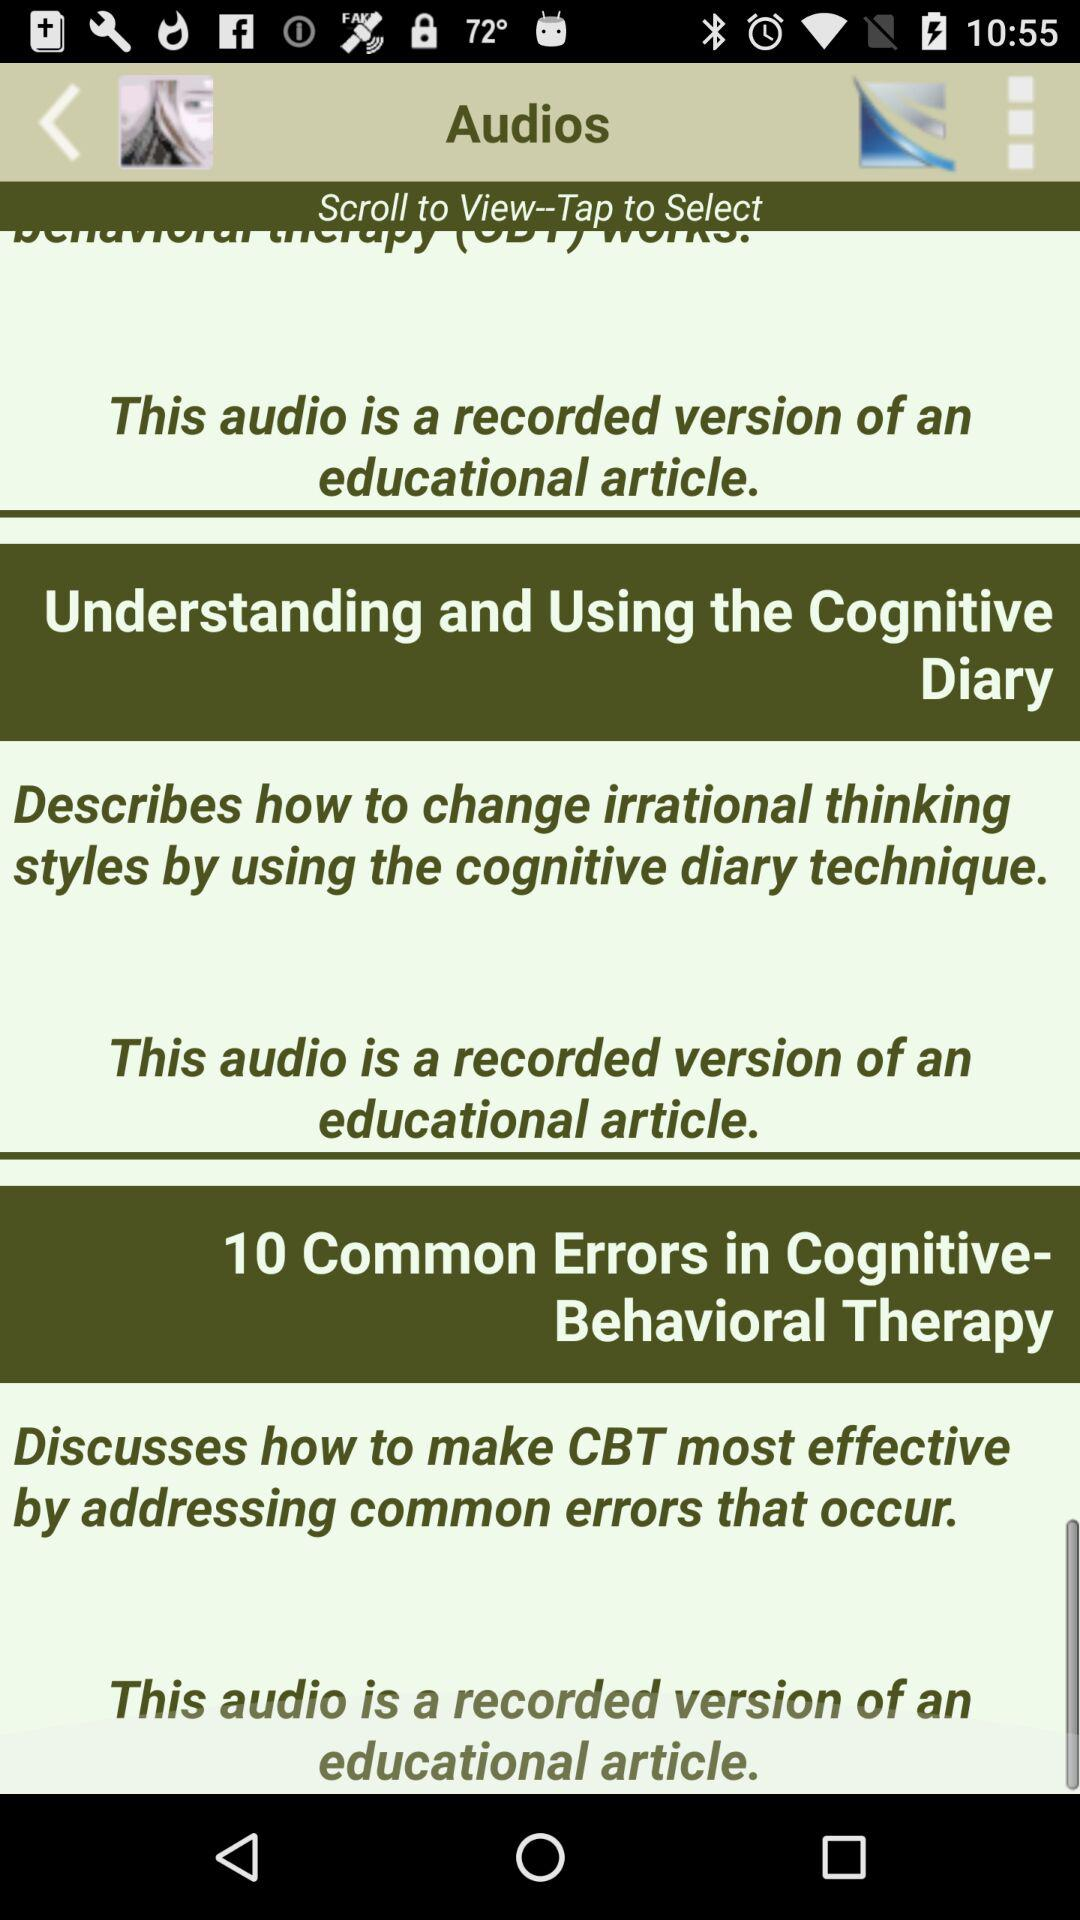Who wrote the educational article "Understanding and Using the Cognitive Diary"?
When the provided information is insufficient, respond with <no answer>. <no answer> 